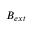<formula> <loc_0><loc_0><loc_500><loc_500>B _ { e x t }</formula> 